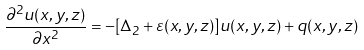<formula> <loc_0><loc_0><loc_500><loc_500>\frac { \partial ^ { 2 } u ( x , y , z ) } { \partial x ^ { 2 } } = - [ \Delta _ { 2 } + \varepsilon ( x , y , z ) ] u ( x , y , z ) + q ( x , y , z )</formula> 